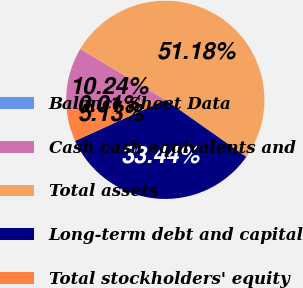<chart> <loc_0><loc_0><loc_500><loc_500><pie_chart><fcel>Balance Sheet Data<fcel>Cash cash equivalents and<fcel>Total assets<fcel>Long-term debt and capital<fcel>Total stockholders' equity<nl><fcel>0.01%<fcel>10.24%<fcel>51.18%<fcel>33.44%<fcel>5.13%<nl></chart> 